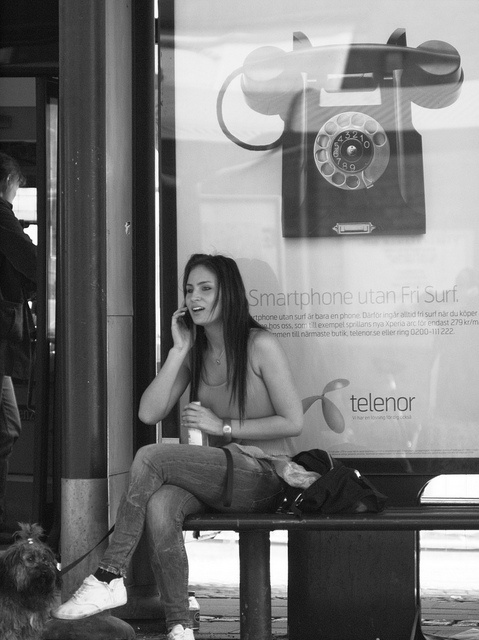Describe the objects in this image and their specific colors. I can see people in black, gray, darkgray, and lightgray tones, bench in black, gray, white, and darkgray tones, people in black, gray, darkgray, and white tones, dog in black, gray, darkgray, and lightgray tones, and handbag in black, gray, darkgray, and white tones in this image. 